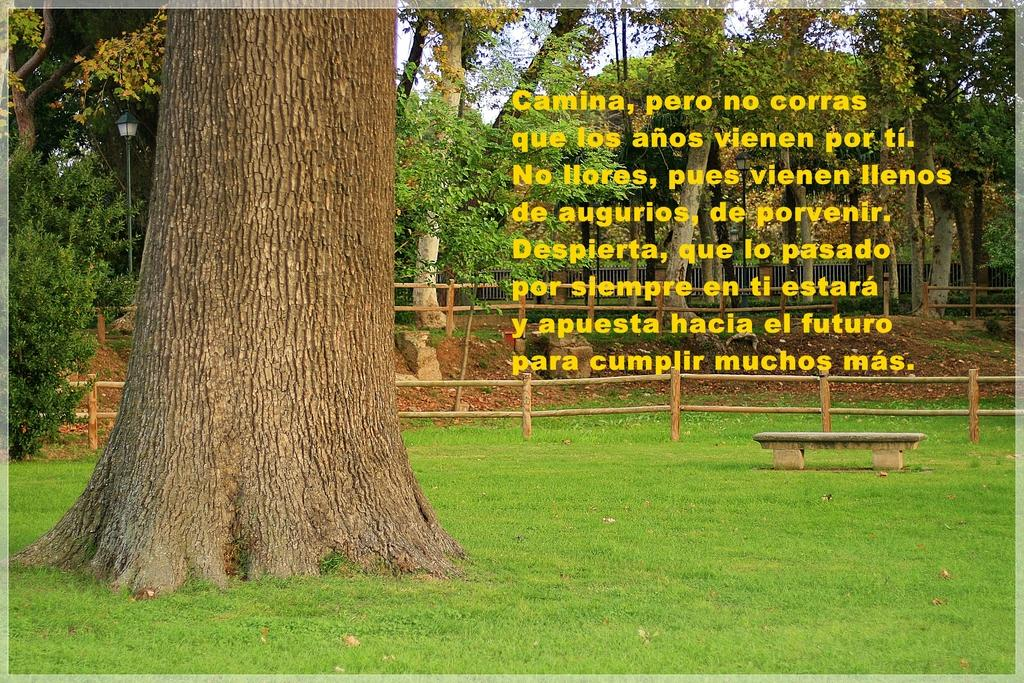What is located on the ground in the image? There is a tree on the ground in the image. What is a piece of furniture that can be seen in the image? There is a bench in the image. What type of material is used for the fencing in the image? The fencing in the image is made of wood. What can be seen in the background of the image? There are trees, a street light pole, and fencing in the background of the image. What part of the natural environment is visible in the image? The sky is visible in the background of the image. What type of coat is hanging on the tree in the image? There is no coat present in the image; it features a tree, a bench, and wooden fencing. How does the land in the image provide comfort to the people? The image does not depict any people or the concept of comfort related to the land. 